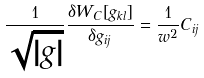Convert formula to latex. <formula><loc_0><loc_0><loc_500><loc_500>\frac { 1 } { \sqrt { | g | } } \frac { \delta W _ { C } [ g _ { k l } ] } { \delta g _ { i j } } = \frac { 1 } { w ^ { 2 } } C _ { i j }</formula> 